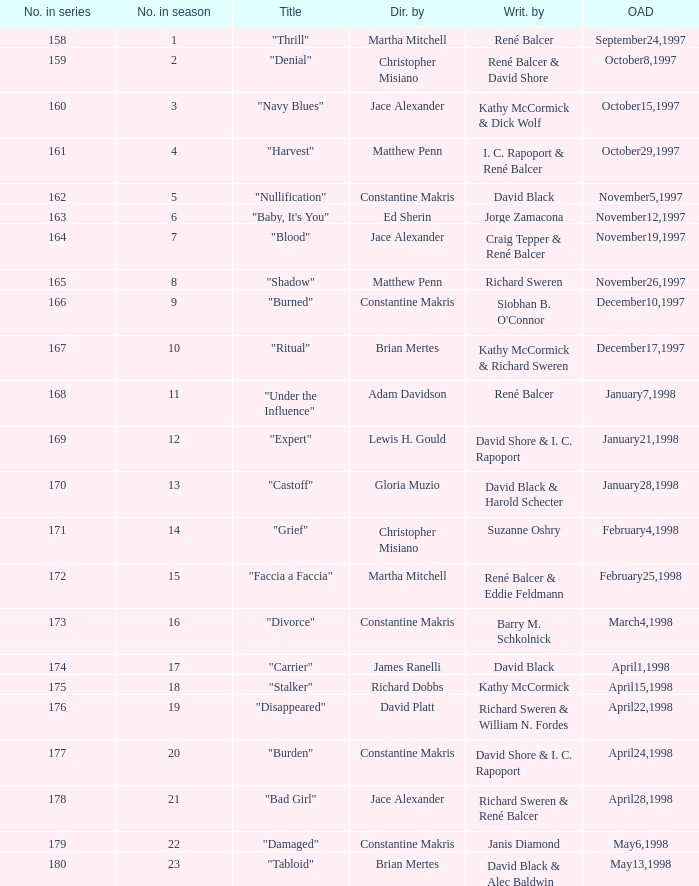Can you parse all the data within this table? {'header': ['No. in series', 'No. in season', 'Title', 'Dir. by', 'Writ. by', 'OAD'], 'rows': [['158', '1', '"Thrill"', 'Martha Mitchell', 'René Balcer', 'September24,1997'], ['159', '2', '"Denial"', 'Christopher Misiano', 'René Balcer & David Shore', 'October8,1997'], ['160', '3', '"Navy Blues"', 'Jace Alexander', 'Kathy McCormick & Dick Wolf', 'October15,1997'], ['161', '4', '"Harvest"', 'Matthew Penn', 'I. C. Rapoport & René Balcer', 'October29,1997'], ['162', '5', '"Nullification"', 'Constantine Makris', 'David Black', 'November5,1997'], ['163', '6', '"Baby, It\'s You"', 'Ed Sherin', 'Jorge Zamacona', 'November12,1997'], ['164', '7', '"Blood"', 'Jace Alexander', 'Craig Tepper & René Balcer', 'November19,1997'], ['165', '8', '"Shadow"', 'Matthew Penn', 'Richard Sweren', 'November26,1997'], ['166', '9', '"Burned"', 'Constantine Makris', "Siobhan B. O'Connor", 'December10,1997'], ['167', '10', '"Ritual"', 'Brian Mertes', 'Kathy McCormick & Richard Sweren', 'December17,1997'], ['168', '11', '"Under the Influence"', 'Adam Davidson', 'René Balcer', 'January7,1998'], ['169', '12', '"Expert"', 'Lewis H. Gould', 'David Shore & I. C. Rapoport', 'January21,1998'], ['170', '13', '"Castoff"', 'Gloria Muzio', 'David Black & Harold Schecter', 'January28,1998'], ['171', '14', '"Grief"', 'Christopher Misiano', 'Suzanne Oshry', 'February4,1998'], ['172', '15', '"Faccia a Faccia"', 'Martha Mitchell', 'René Balcer & Eddie Feldmann', 'February25,1998'], ['173', '16', '"Divorce"', 'Constantine Makris', 'Barry M. Schkolnick', 'March4,1998'], ['174', '17', '"Carrier"', 'James Ranelli', 'David Black', 'April1,1998'], ['175', '18', '"Stalker"', 'Richard Dobbs', 'Kathy McCormick', 'April15,1998'], ['176', '19', '"Disappeared"', 'David Platt', 'Richard Sweren & William N. Fordes', 'April22,1998'], ['177', '20', '"Burden"', 'Constantine Makris', 'David Shore & I. C. Rapoport', 'April24,1998'], ['178', '21', '"Bad Girl"', 'Jace Alexander', 'Richard Sweren & René Balcer', 'April28,1998'], ['179', '22', '"Damaged"', 'Constantine Makris', 'Janis Diamond', 'May6,1998'], ['180', '23', '"Tabloid"', 'Brian Mertes', 'David Black & Alec Baldwin', 'May13,1998']]} Name the title of the episode that ed sherin directed. "Baby, It's You". 